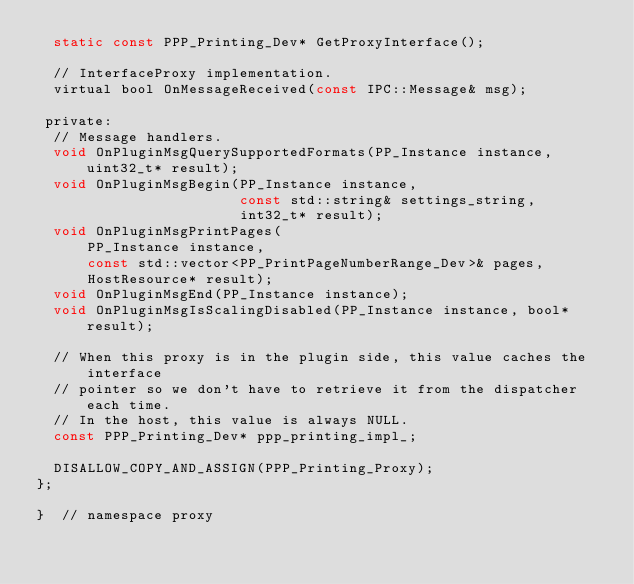<code> <loc_0><loc_0><loc_500><loc_500><_C_>  static const PPP_Printing_Dev* GetProxyInterface();

  // InterfaceProxy implementation.
  virtual bool OnMessageReceived(const IPC::Message& msg);

 private:
  // Message handlers.
  void OnPluginMsgQuerySupportedFormats(PP_Instance instance, uint32_t* result);
  void OnPluginMsgBegin(PP_Instance instance,
                        const std::string& settings_string,
                        int32_t* result);
  void OnPluginMsgPrintPages(
      PP_Instance instance,
      const std::vector<PP_PrintPageNumberRange_Dev>& pages,
      HostResource* result);
  void OnPluginMsgEnd(PP_Instance instance);
  void OnPluginMsgIsScalingDisabled(PP_Instance instance, bool* result);

  // When this proxy is in the plugin side, this value caches the interface
  // pointer so we don't have to retrieve it from the dispatcher each time.
  // In the host, this value is always NULL.
  const PPP_Printing_Dev* ppp_printing_impl_;

  DISALLOW_COPY_AND_ASSIGN(PPP_Printing_Proxy);
};

}  // namespace proxy</code> 